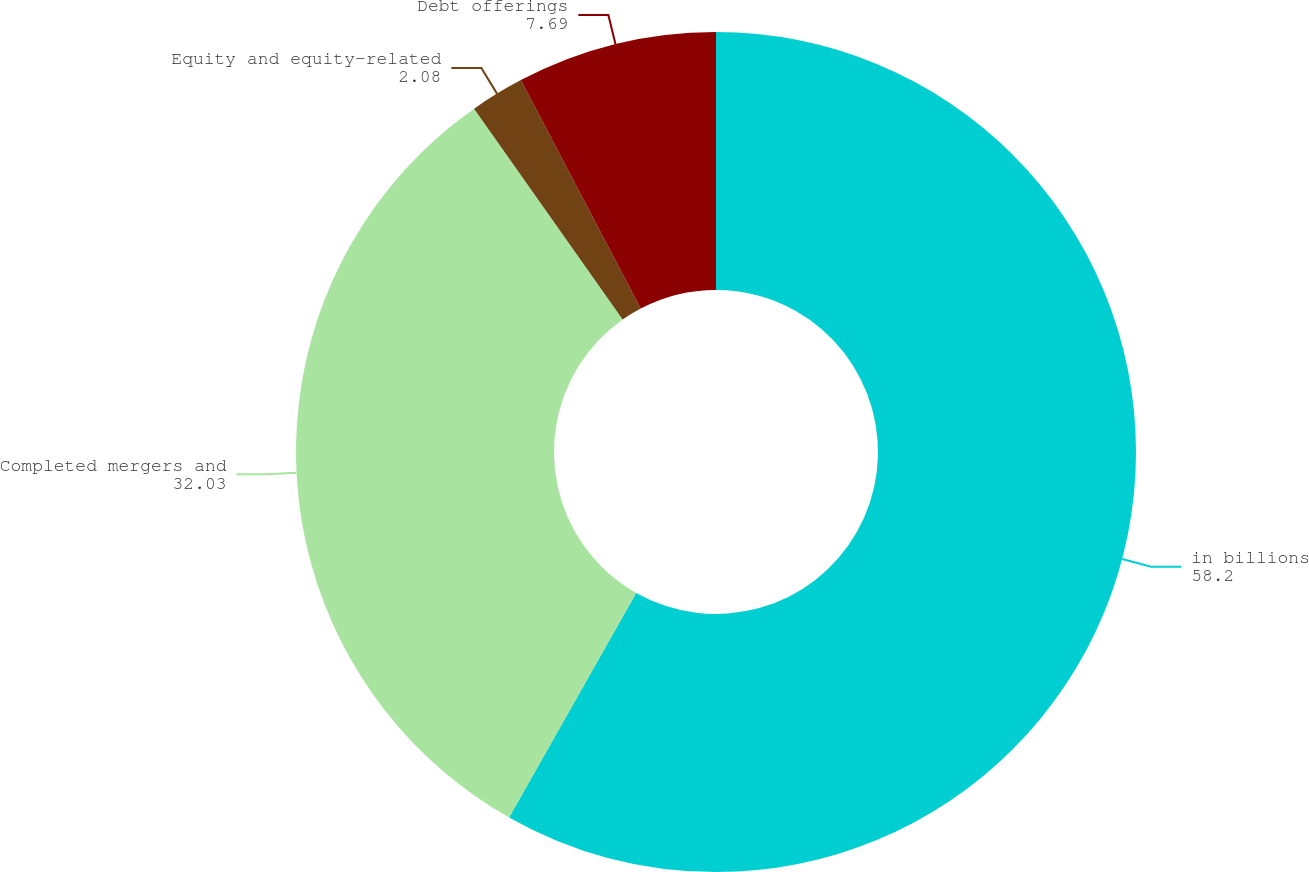Convert chart. <chart><loc_0><loc_0><loc_500><loc_500><pie_chart><fcel>in billions<fcel>Completed mergers and<fcel>Equity and equity-related<fcel>Debt offerings<nl><fcel>58.2%<fcel>32.03%<fcel>2.08%<fcel>7.69%<nl></chart> 